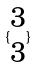<formula> <loc_0><loc_0><loc_500><loc_500>\{ \begin{matrix} 3 \\ 3 \end{matrix} \}</formula> 